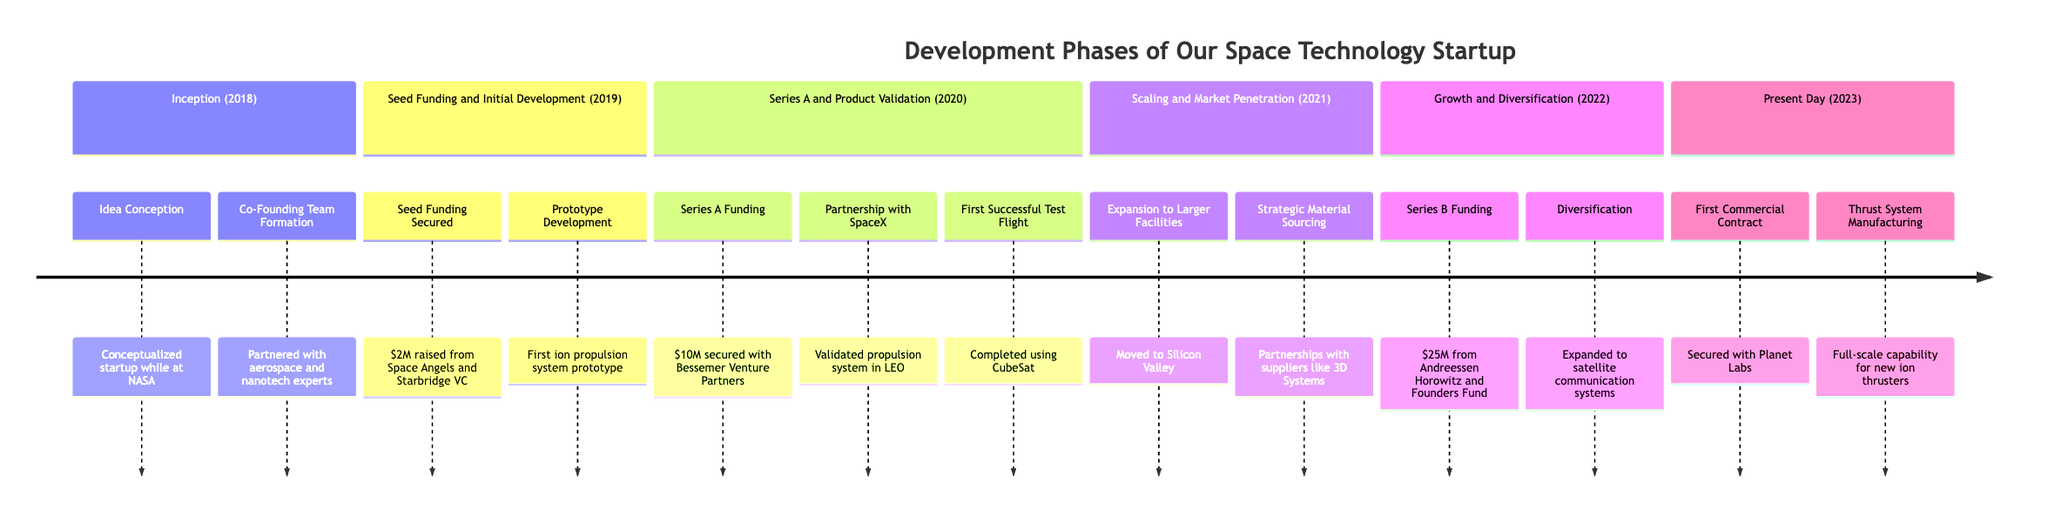What year did the startup's inception phase occur? The diagram specifies that the "Inception" phase occurred in the year 2018. This can be found at the top section of the timeline.
Answer: 2018 How much seed funding was raised in 2019? In the timeline section for "Seed Funding and Initial Development" in 2019, it states that $2M was raised. This is a clear numerical detail provided under that phase.
Answer: $2M What was the first successful milestone achieved in 2020? The "First Successful Test Flight" is the first milestone listed under the "Series A and Product Validation" section for 2020. It indicates that this milestone was achieved after the funding.
Answer: First Successful Test Flight Which partnership was formed in 2020? The timeline indicates a partnership with SpaceX was established in 2020. This information is specifically mentioned under the "Series A and Product Validation" section.
Answer: Partnership with SpaceX What type of funding was closed in 2022? In the "Growth and Diversification" section for 2022, it mentions a "Series B Funding" round closed. This denotes the type of funding acquired that year.
Answer: Series B Funding How many milestones were achieved in 2021? There are two milestones listed in the "Scaling and Market Penetration" phase for 2021. These milestones are "Expansion to Larger Facilities" and "Strategic Material Sourcing," indicating that a total of two were achieved that year.
Answer: 2 In which phase did the company start to diversify its product line? The timeline shows that diversification into satellite technology occurred in 2022, specifically noted under the "Growth and Diversification" section, indicating the phase in which this happened.
Answer: Growth and Diversification What significant operational change occurred in 2021? The timeline states that the company moved operations to a larger facility in Silicon Valley, which is a key operational change under the "Scaling and Market Penetration" section.
Answer: Expansion to Larger Facilities What is the latest milestone as of 2023? The last milestone featured in the "Present Day" section for 2023 is "Thrust System Manufacturing," which highlights the current achievement of the company up to that year.
Answer: Thrust System Manufacturing 